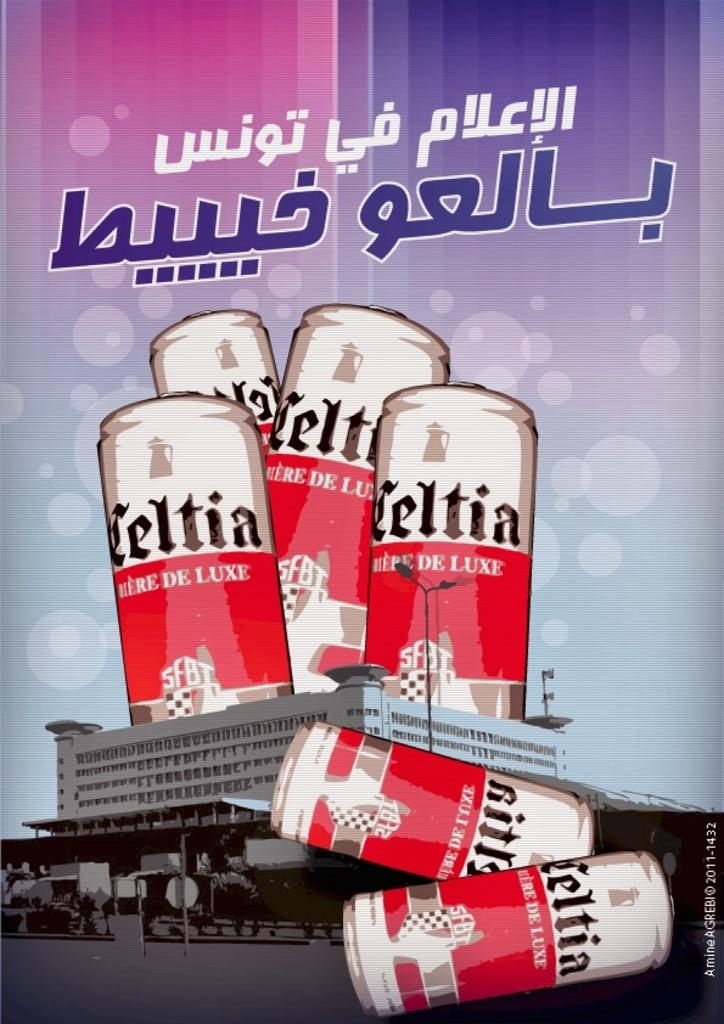Provide a one-sentence caption for the provided image. An advertisemen shows several large cans of Celtia Deluxe o top of a building. 